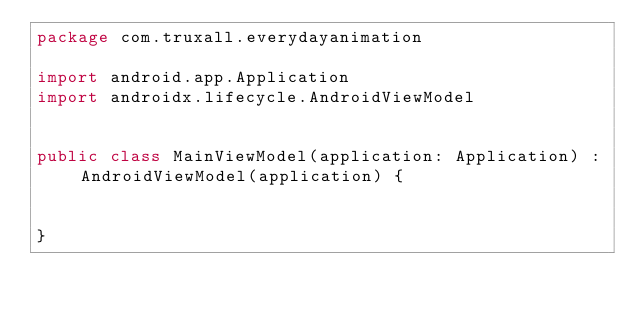<code> <loc_0><loc_0><loc_500><loc_500><_Kotlin_>package com.truxall.everydayanimation

import android.app.Application
import androidx.lifecycle.AndroidViewModel


public class MainViewModel(application: Application) : AndroidViewModel(application) {


}</code> 